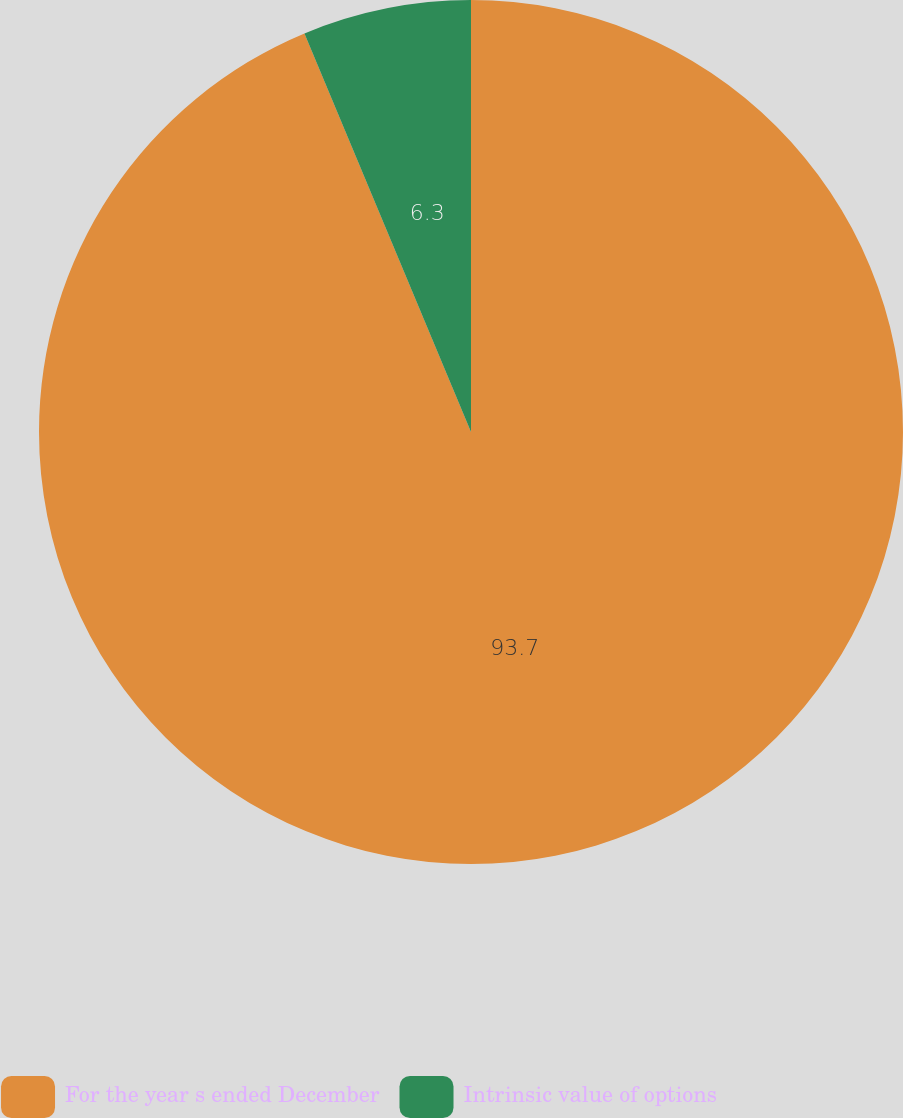<chart> <loc_0><loc_0><loc_500><loc_500><pie_chart><fcel>For the year s ended December<fcel>Intrinsic value of options<nl><fcel>93.7%<fcel>6.3%<nl></chart> 